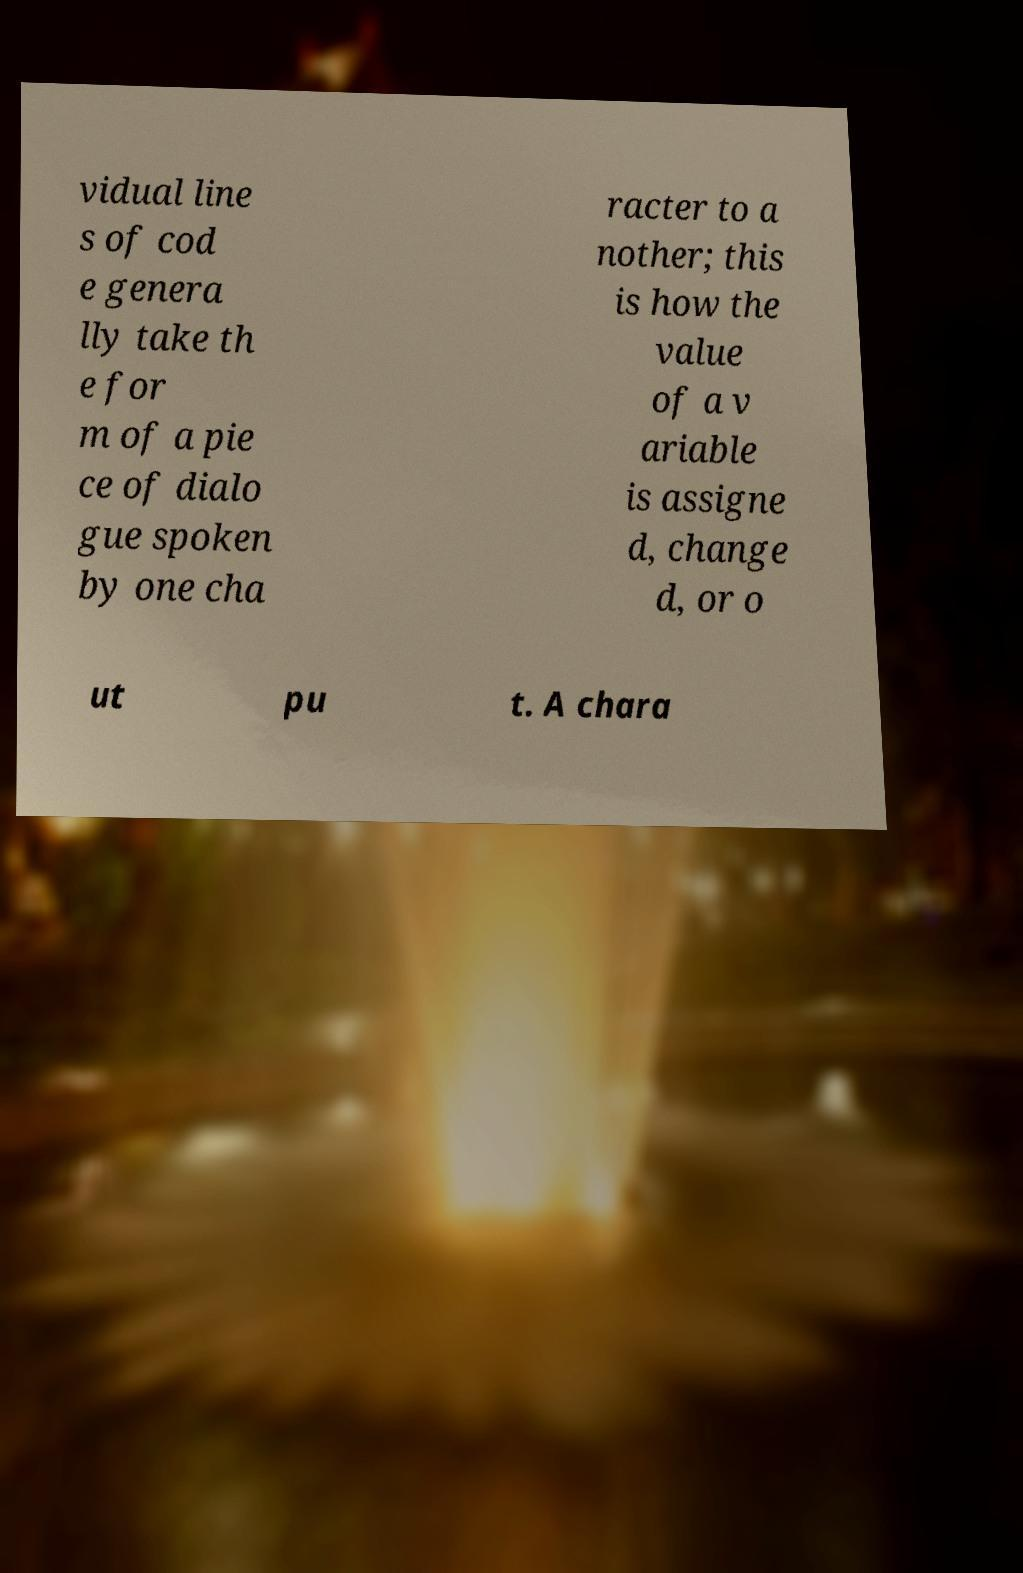Please identify and transcribe the text found in this image. vidual line s of cod e genera lly take th e for m of a pie ce of dialo gue spoken by one cha racter to a nother; this is how the value of a v ariable is assigne d, change d, or o ut pu t. A chara 